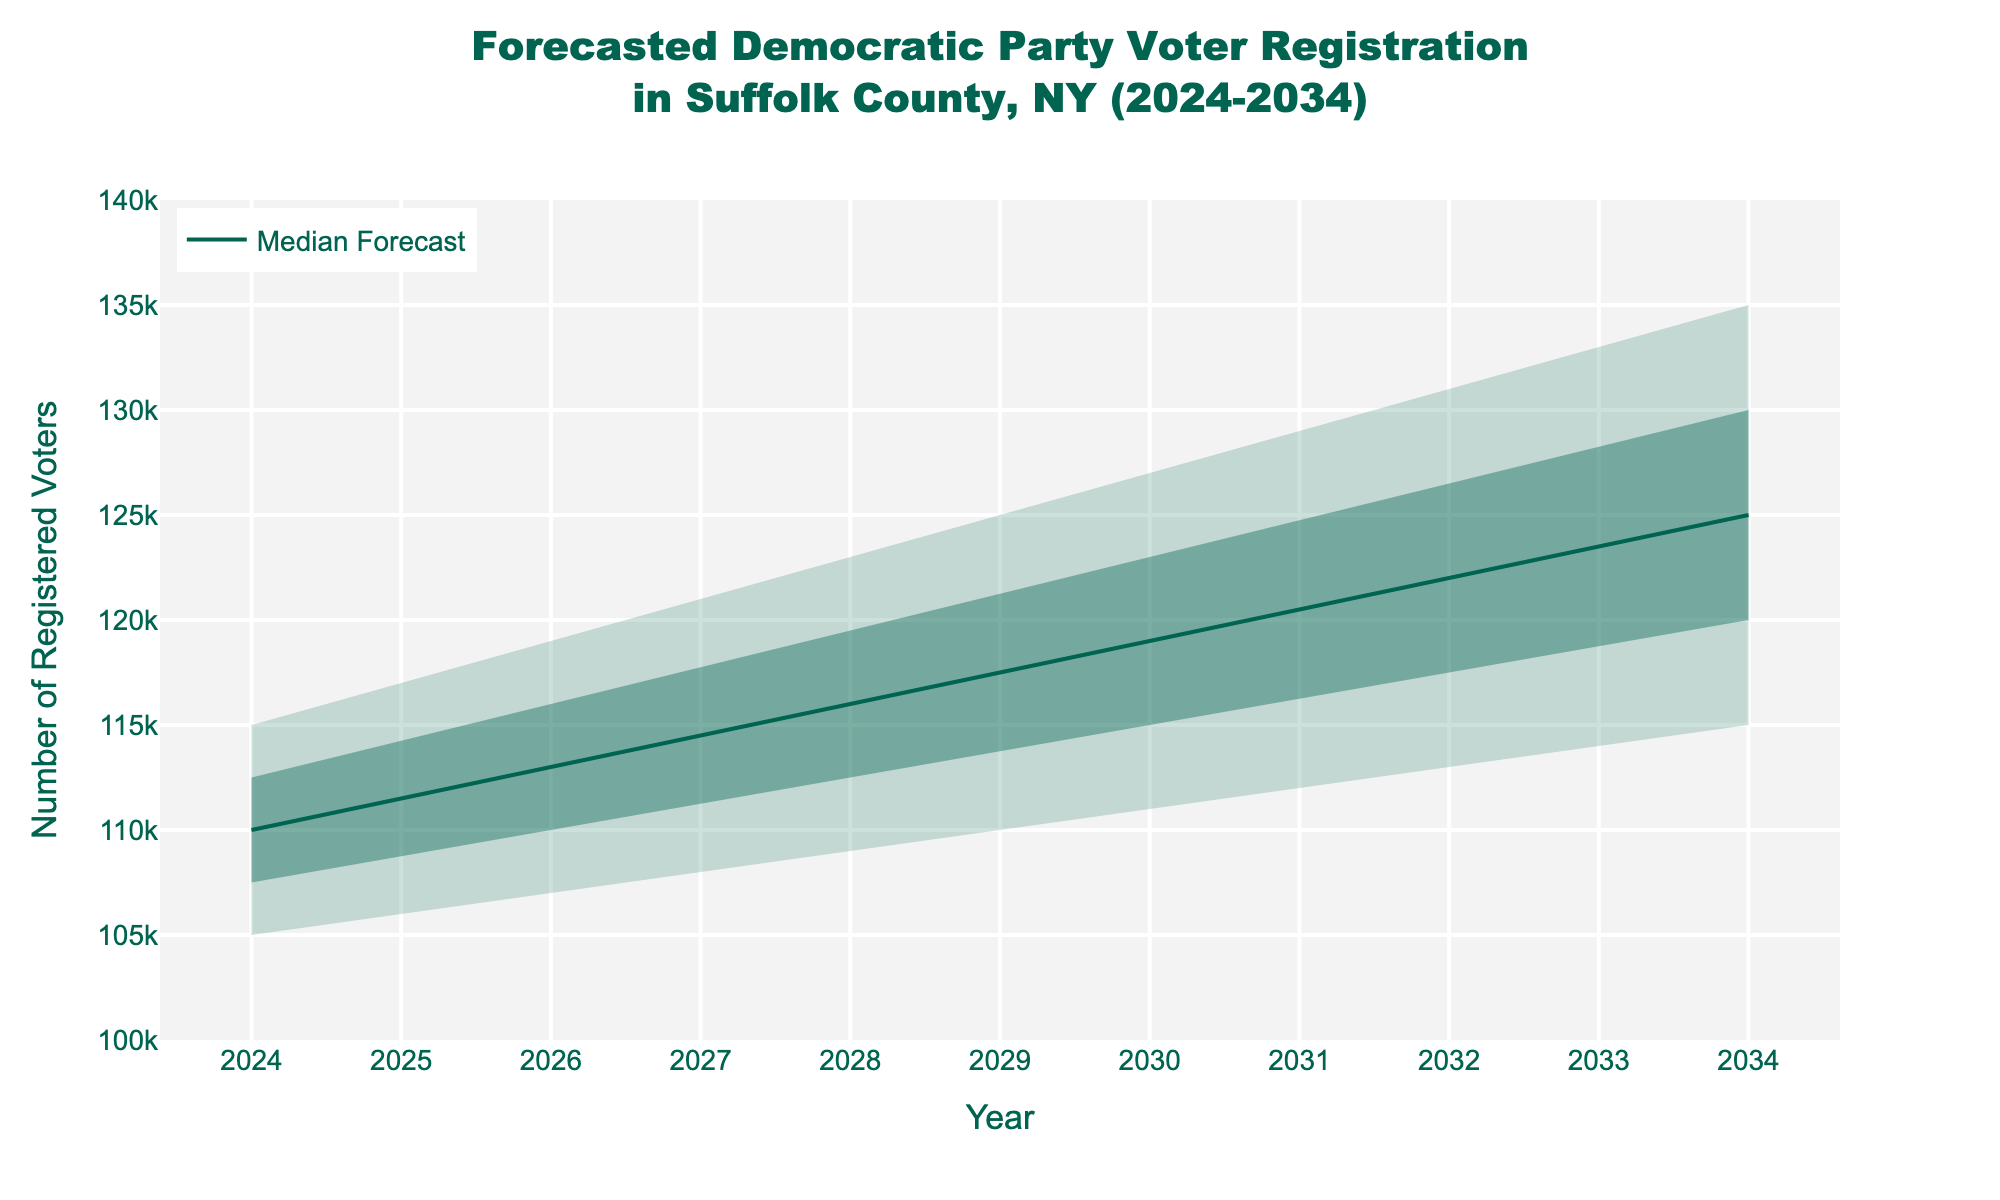What is the mid-range forecast for Democratic Party voter registration in 2030? The mid-range forecast is given by the "Mid" value for the year 2030. Referring to the figure, the median forecast for 2030 is 119,000 voters.
Answer: 119,000 How does the high estimate for 2034 compare to the high estimate for 2024? To compare the high estimates, find the values for 2024 and 2034 from the figure. In 2024, the high estimate is 115,000 voters, while in 2034, it is 135,000 voters. 135,000 is 20,000 more than 115,000.
Answer: It's 20,000 higher What is the forecasted range (difference between highest and lowest estimates) of voters for 2028? The range is calculated by subtracting the lowest estimate from the highest estimate for 2028. The high estimate is 123,000, and the low estimate is 109,000, so the range is 123,000 - 109,000 = 14,000.
Answer: 14,000 Which year shows the smallest difference between the mid and low voter registration forecasts? To find the smallest difference, subtract the low estimate from the mid estimate for each year and compare them. For example, in 2024: 110,000 - 105,000 = 5,000. Repeat for all years and see that 2024 has the smallest difference of 5,000.
Answer: 2024 What's the maximum projected number of registered Democratic voters in the next decade? The maximum is found in the "High" column for 2034, which is the highest number of all high estimates. Referring to the figure, this number is 135,000.
Answer: 135,000 What is the trend of the median forecast from 2024 to 2034? Look at the median forecast values from 2024 to 2034 and observe the trend. The trends are: 110,000 in 2024, 113,000 in 2026, 116,000 in 2028, 119,000 in 2030, 122,000 in 2032, 125,000 in 2034. The trend shows a steady increase.
Answer: Steady increase How does voter registration forecast for 2030 differ when comparing the mid-high and low-mid ranges? To find the difference, subtract the low-mid estimate from the mid-high estimate for 2030. From the figure, the mid-high is 123,000 and the low-mid is 115,000, so 123,000 - 115,000 = 8,000.
Answer: 8,000 Between which years does the mid-range voter registration forecast increase the most? Calculate the difference between consecutive mid-range values and identify the largest increase. Differences are: 2026-2024 = 3,000; 2028-2026 = 3,000; 2030-2028 = 3,000; 2032-2030 = 3,000; 2034-2032 = 3,000. All are 3,000, so there is no single year with a larger increase.
Answer: No difference What is the median voter registration forecast for 2034? Check the "Mid" column for 2034. The value is 125,000, which represents the median voter registration forecast.
Answer: 125,000 